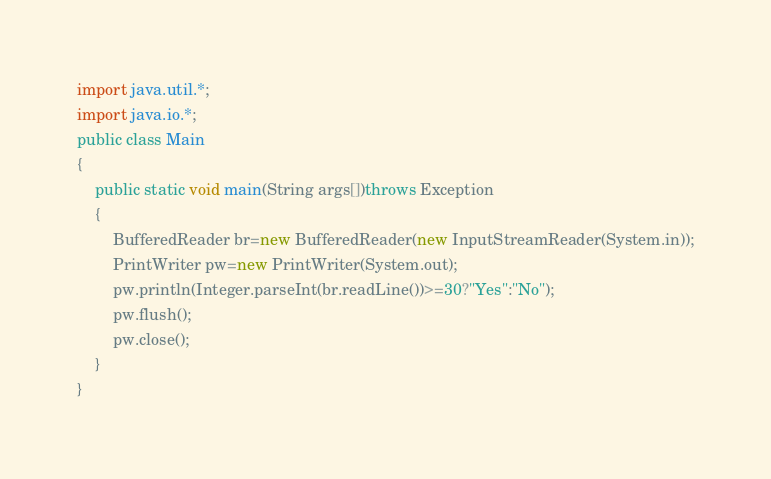<code> <loc_0><loc_0><loc_500><loc_500><_Java_>import java.util.*;
import java.io.*;
public class Main
{
    public static void main(String args[])throws Exception
    {
        BufferedReader br=new BufferedReader(new InputStreamReader(System.in));
        PrintWriter pw=new PrintWriter(System.out);
        pw.println(Integer.parseInt(br.readLine())>=30?"Yes":"No");
        pw.flush();
        pw.close();
    }
}</code> 